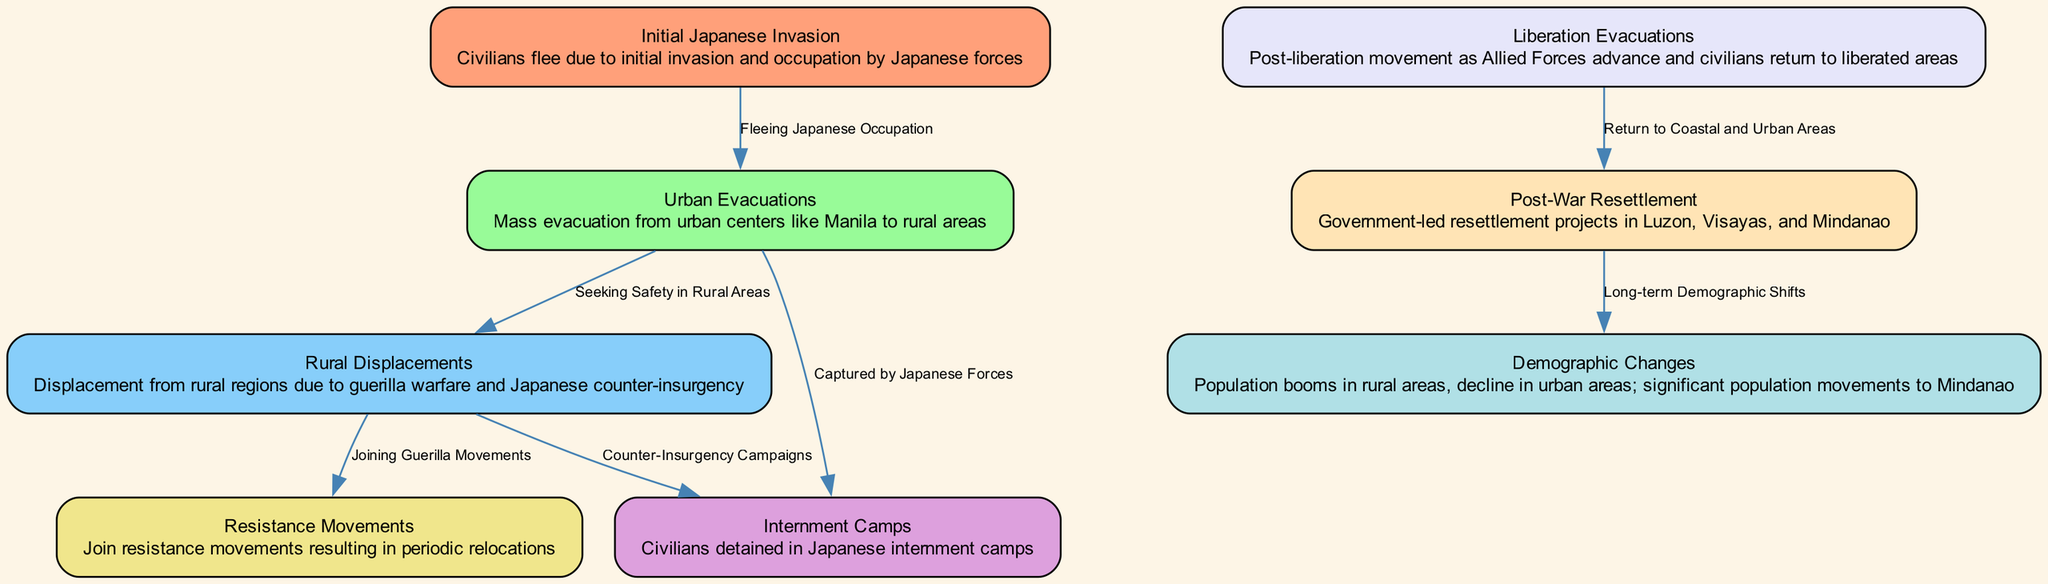What is the first node in the diagram? The first node in the diagram is "Initial Japanese Invasion." It represents the starting point of the migration pattern during WWII in the Philippines.
Answer: Initial Japanese Invasion How many nodes are present in the diagram? To determine the number of nodes, I counted each unique location and event listed in the nodes section. There are a total of 8 nodes.
Answer: 8 What is the label of the node that describes the mass evacuation from urban centers? The node that describes the mass evacuation from urban centers is labeled "Urban Evacuations." This indicates the movement of civilians seeking safety.
Answer: Urban Evacuations What movement follows the "Rural Displacements" node? The movement that follows the "Rural Displacements" node is represented by two possible paths: "Internment Camps" (due to counter-insurgency campaigns) and "Resistance Movements" (for joining guerilla movements). This branch shows the choices civilians faced during displacement.
Answer: Internment Camps and Resistance Movements Which node indicates the post-liberation movement? The node that indicates the post-liberation movement is labeled "Liberation Evacuations." This node reflects the return of civilians as Allied Forces advance.
Answer: Liberation Evacuations What does the "Demographic Changes" node represent? The "Demographic Changes" node represents the long-term shifts in the population as a result of the movements described in earlier nodes, including booms in rural areas and declines in urban ones.
Answer: Population booms in rural areas, decline in urban areas Which nodes are connected through the edge labeled "Fleeing Japanese Occupation"? The edge labeled "Fleeing Japanese Occupation" connects the "Initial Japanese Invasion" node to the "Urban Evacuations" node. It shows the direct consequence of the invasion, motivating civilians to evacuate urban areas.
Answer: Initial Japanese Invasion and Urban Evacuations What type of government initiatives are mentioned in the post-war period? The diagram mentions "Government-led resettlement projects" in the post-war period, indicating efforts to resettle displaced populations in Luzon, Visayas, and Mindanao.
Answer: Government-led resettlement projects What are the long-term impacts highlighted in the diagram? The long-term impacts highlighted in the diagram include demographic changes, such as population booms in rural areas and a significant movement to Mindanao due to post-war resettlement strategies.
Answer: Long-term demographic shifts 